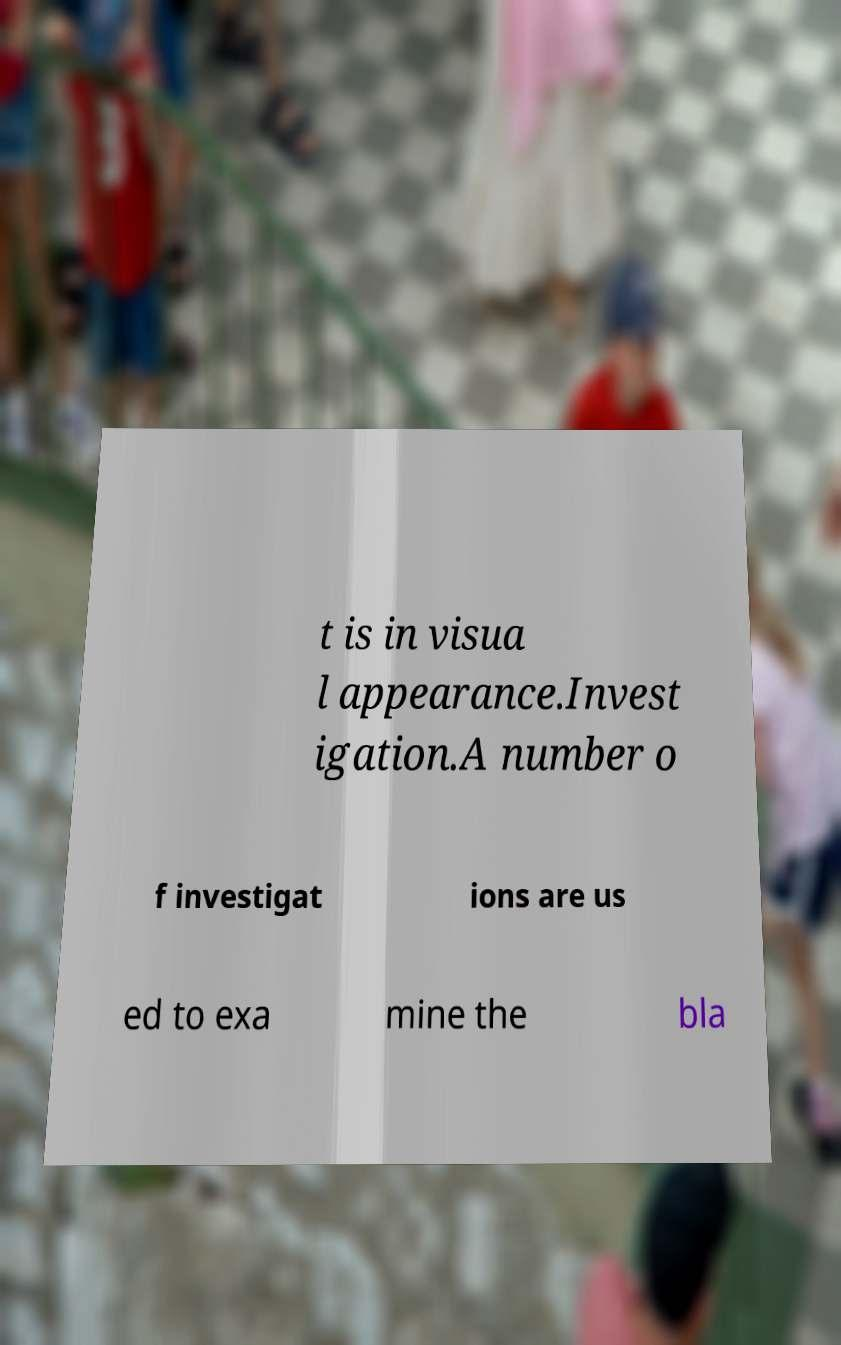I need the written content from this picture converted into text. Can you do that? t is in visua l appearance.Invest igation.A number o f investigat ions are us ed to exa mine the bla 